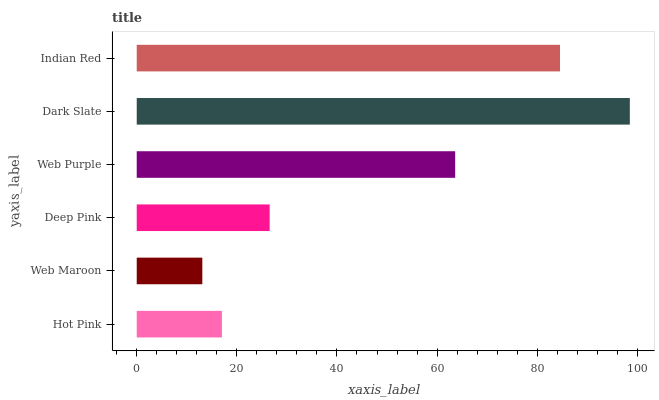Is Web Maroon the minimum?
Answer yes or no. Yes. Is Dark Slate the maximum?
Answer yes or no. Yes. Is Deep Pink the minimum?
Answer yes or no. No. Is Deep Pink the maximum?
Answer yes or no. No. Is Deep Pink greater than Web Maroon?
Answer yes or no. Yes. Is Web Maroon less than Deep Pink?
Answer yes or no. Yes. Is Web Maroon greater than Deep Pink?
Answer yes or no. No. Is Deep Pink less than Web Maroon?
Answer yes or no. No. Is Web Purple the high median?
Answer yes or no. Yes. Is Deep Pink the low median?
Answer yes or no. Yes. Is Dark Slate the high median?
Answer yes or no. No. Is Indian Red the low median?
Answer yes or no. No. 